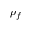<formula> <loc_0><loc_0><loc_500><loc_500>\rho _ { f }</formula> 